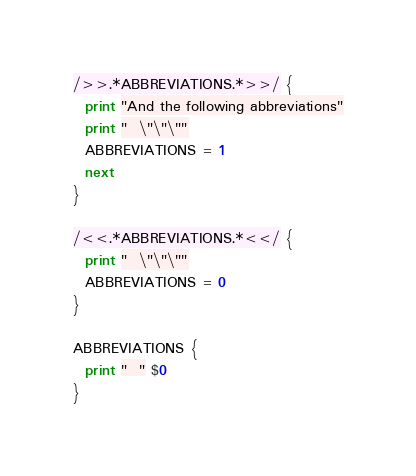Convert code to text. <code><loc_0><loc_0><loc_500><loc_500><_Awk_>/>>.*ABBREVIATIONS.*>>/ {
  print "And the following abbreviations"
  print "  \"\"\""
  ABBREVIATIONS = 1
  next
}

/<<.*ABBREVIATIONS.*<</ {
  print "  \"\"\""
  ABBREVIATIONS = 0
}

ABBREVIATIONS {
  print "  " $0
}
</code> 